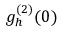Convert formula to latex. <formula><loc_0><loc_0><loc_500><loc_500>g _ { h } ^ { ( 2 ) } ( 0 )</formula> 